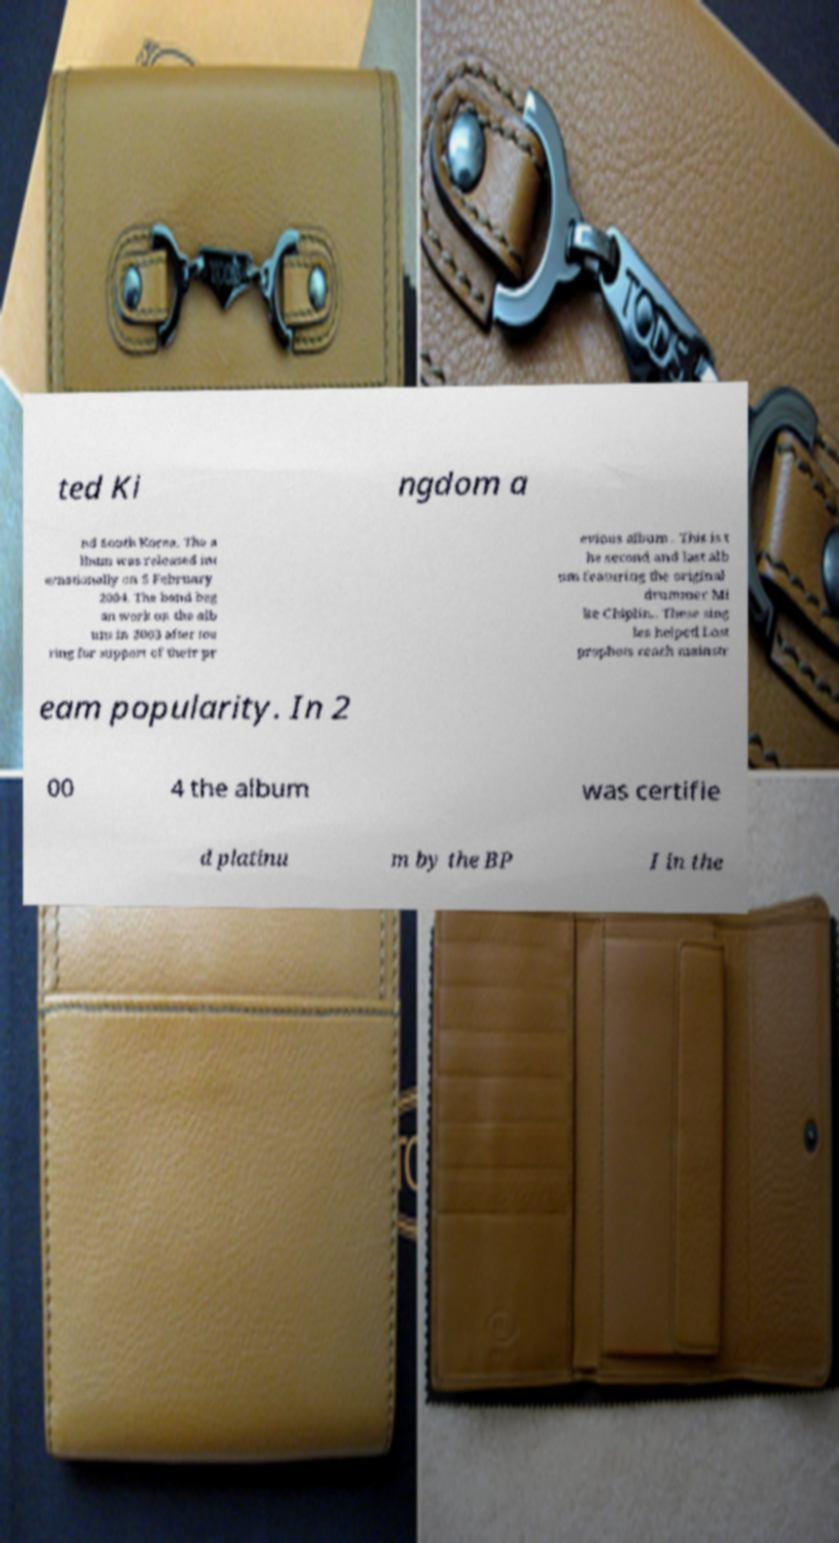Please identify and transcribe the text found in this image. ted Ki ngdom a nd South Korea. The a lbum was released int ernationally on 5 February 2004. The band beg an work on the alb um in 2003 after tou ring for support of their pr evious album . This is t he second and last alb um featuring the original drummer Mi ke Chiplin.. These sing les helped Lost prophets reach mainstr eam popularity. In 2 00 4 the album was certifie d platinu m by the BP I in the 